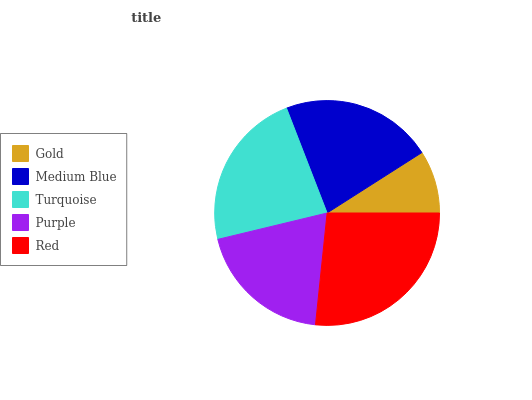Is Gold the minimum?
Answer yes or no. Yes. Is Red the maximum?
Answer yes or no. Yes. Is Medium Blue the minimum?
Answer yes or no. No. Is Medium Blue the maximum?
Answer yes or no. No. Is Medium Blue greater than Gold?
Answer yes or no. Yes. Is Gold less than Medium Blue?
Answer yes or no. Yes. Is Gold greater than Medium Blue?
Answer yes or no. No. Is Medium Blue less than Gold?
Answer yes or no. No. Is Medium Blue the high median?
Answer yes or no. Yes. Is Medium Blue the low median?
Answer yes or no. Yes. Is Purple the high median?
Answer yes or no. No. Is Red the low median?
Answer yes or no. No. 